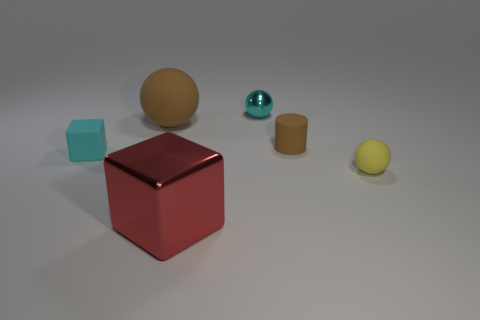There is a object that is the same color as the tiny rubber cube; what material is it?
Ensure brevity in your answer.  Metal. Does the brown rubber cylinder have the same size as the brown matte ball?
Ensure brevity in your answer.  No. Does the tiny sphere that is behind the yellow rubber sphere have the same color as the small rubber cube?
Offer a very short reply. Yes. There is a metal object behind the small yellow rubber sphere; is there a tiny cyan object in front of it?
Offer a terse response. Yes. What material is the object that is on the right side of the brown rubber ball and on the left side of the small cyan sphere?
Offer a very short reply. Metal. The large red thing that is made of the same material as the tiny cyan ball is what shape?
Ensure brevity in your answer.  Cube. Is there anything else that is the same shape as the tiny brown thing?
Your answer should be very brief. No. Are the ball in front of the small brown cylinder and the tiny cyan ball made of the same material?
Make the answer very short. No. What material is the large thing behind the yellow matte thing?
Your response must be concise. Rubber. There is a cube behind the object to the right of the small brown cylinder; what size is it?
Offer a very short reply. Small. 